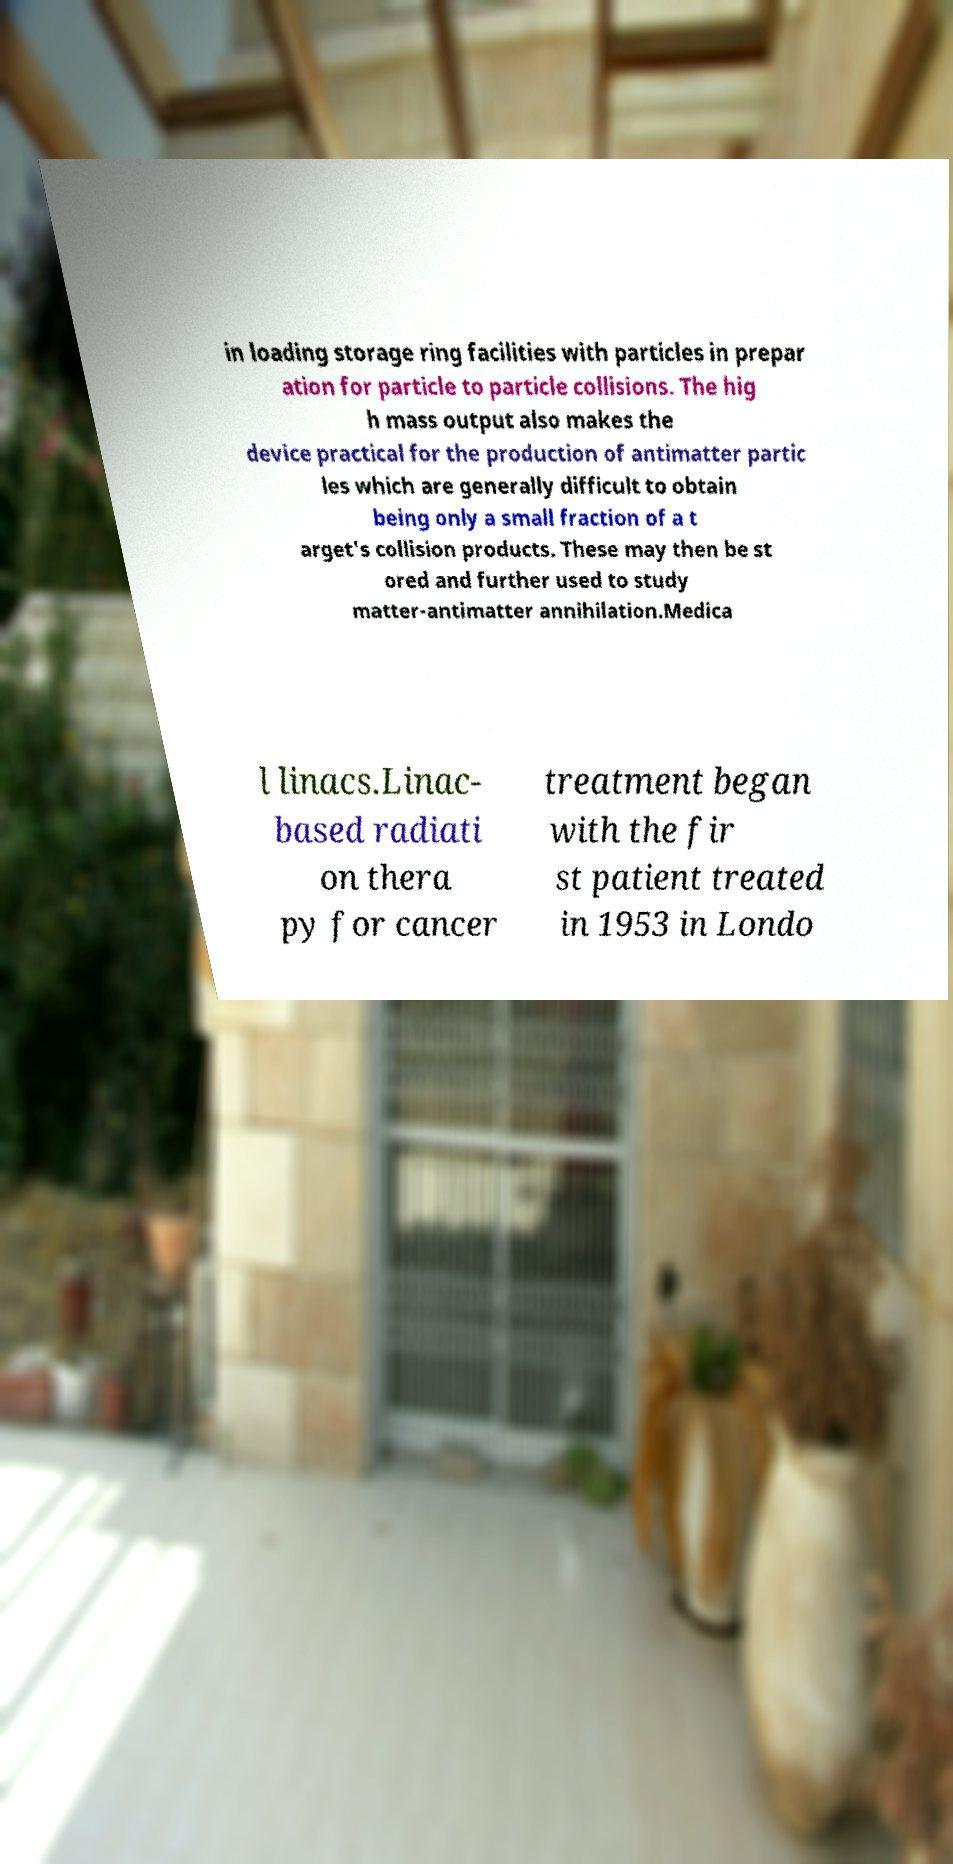Please read and relay the text visible in this image. What does it say? in loading storage ring facilities with particles in prepar ation for particle to particle collisions. The hig h mass output also makes the device practical for the production of antimatter partic les which are generally difficult to obtain being only a small fraction of a t arget's collision products. These may then be st ored and further used to study matter-antimatter annihilation.Medica l linacs.Linac- based radiati on thera py for cancer treatment began with the fir st patient treated in 1953 in Londo 